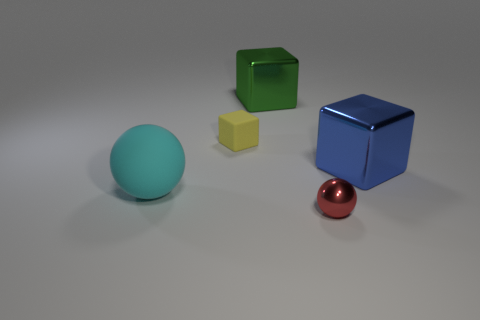Add 5 tiny brown metal cylinders. How many objects exist? 10 Subtract all cubes. How many objects are left? 2 Add 4 big green metallic balls. How many big green metallic balls exist? 4 Subtract 0 gray balls. How many objects are left? 5 Subtract all red metallic objects. Subtract all small green matte spheres. How many objects are left? 4 Add 1 green metal things. How many green metal things are left? 2 